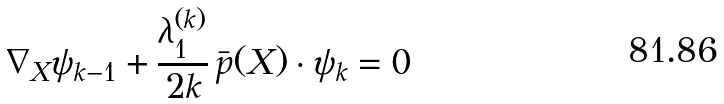<formula> <loc_0><loc_0><loc_500><loc_500>\nabla _ { X } \psi _ { k - 1 } + \frac { \lambda ^ { ( k ) } _ { 1 } } { 2 k } \, \bar { p } ( X ) \cdot \psi _ { k } = 0</formula> 